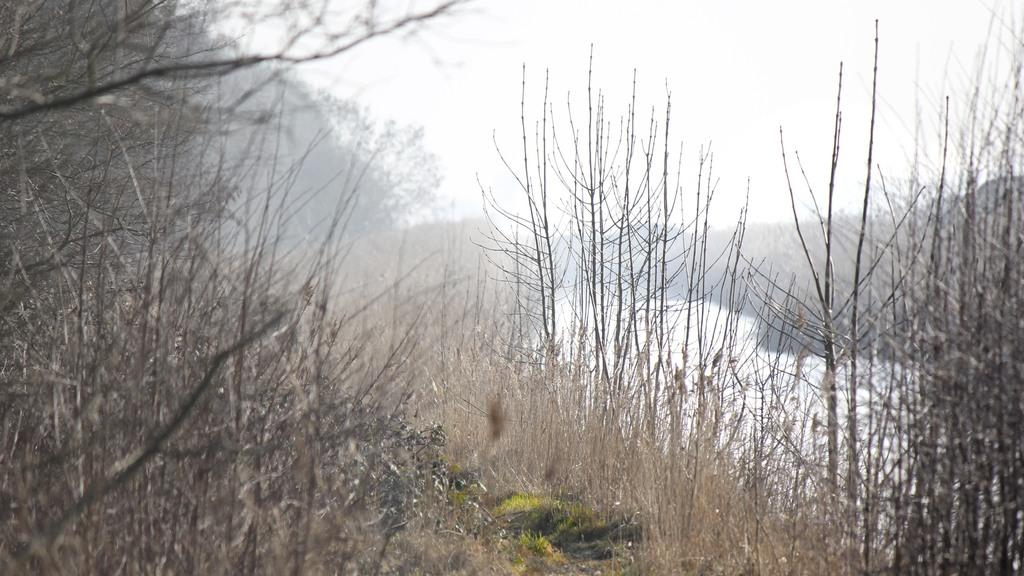What type of plants are in the image? There are dry plants in the image. What can be seen on the right side of the image? There is a river on the right side of the image. What is visible at the top of the image? The sky is visible at the top of the image. What type of milk is being poured into the river in the image? There is no milk present in the image, and no pouring is taking place. 